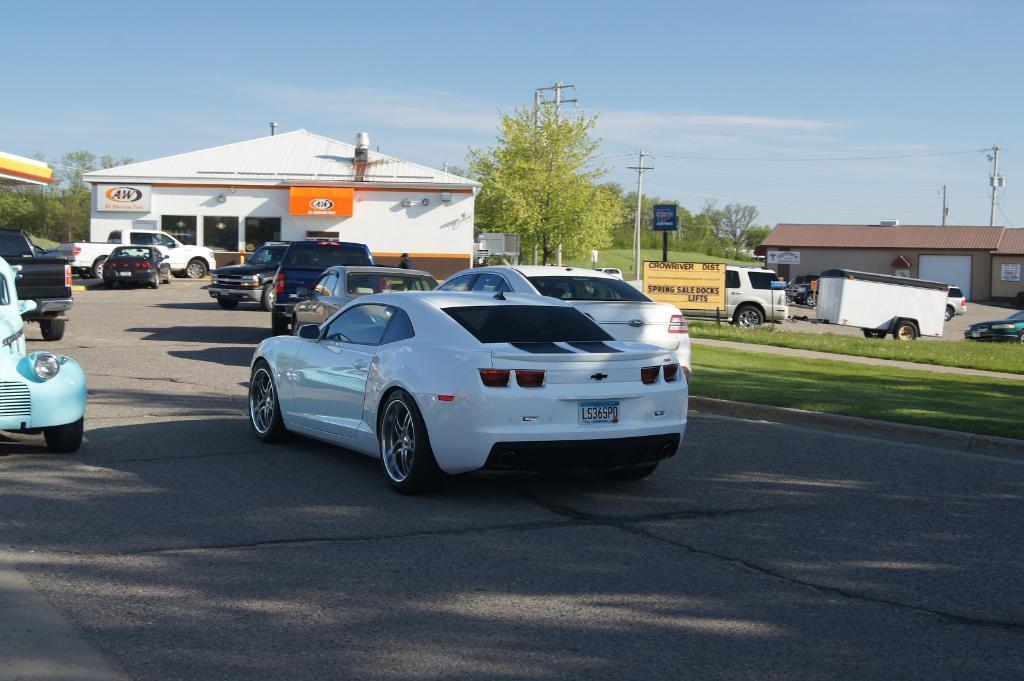Could you give a brief overview of what you see in this image? In this image we can see vehicles on the road. Here we can see the grass, boards, current poles, wires, houses, trees and the sky in the background. 